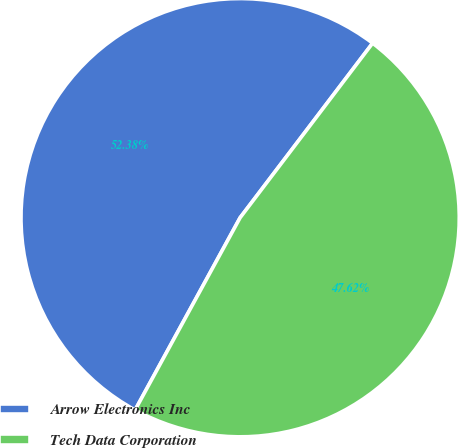Convert chart to OTSL. <chart><loc_0><loc_0><loc_500><loc_500><pie_chart><fcel>Arrow Electronics Inc<fcel>Tech Data Corporation<nl><fcel>52.38%<fcel>47.62%<nl></chart> 